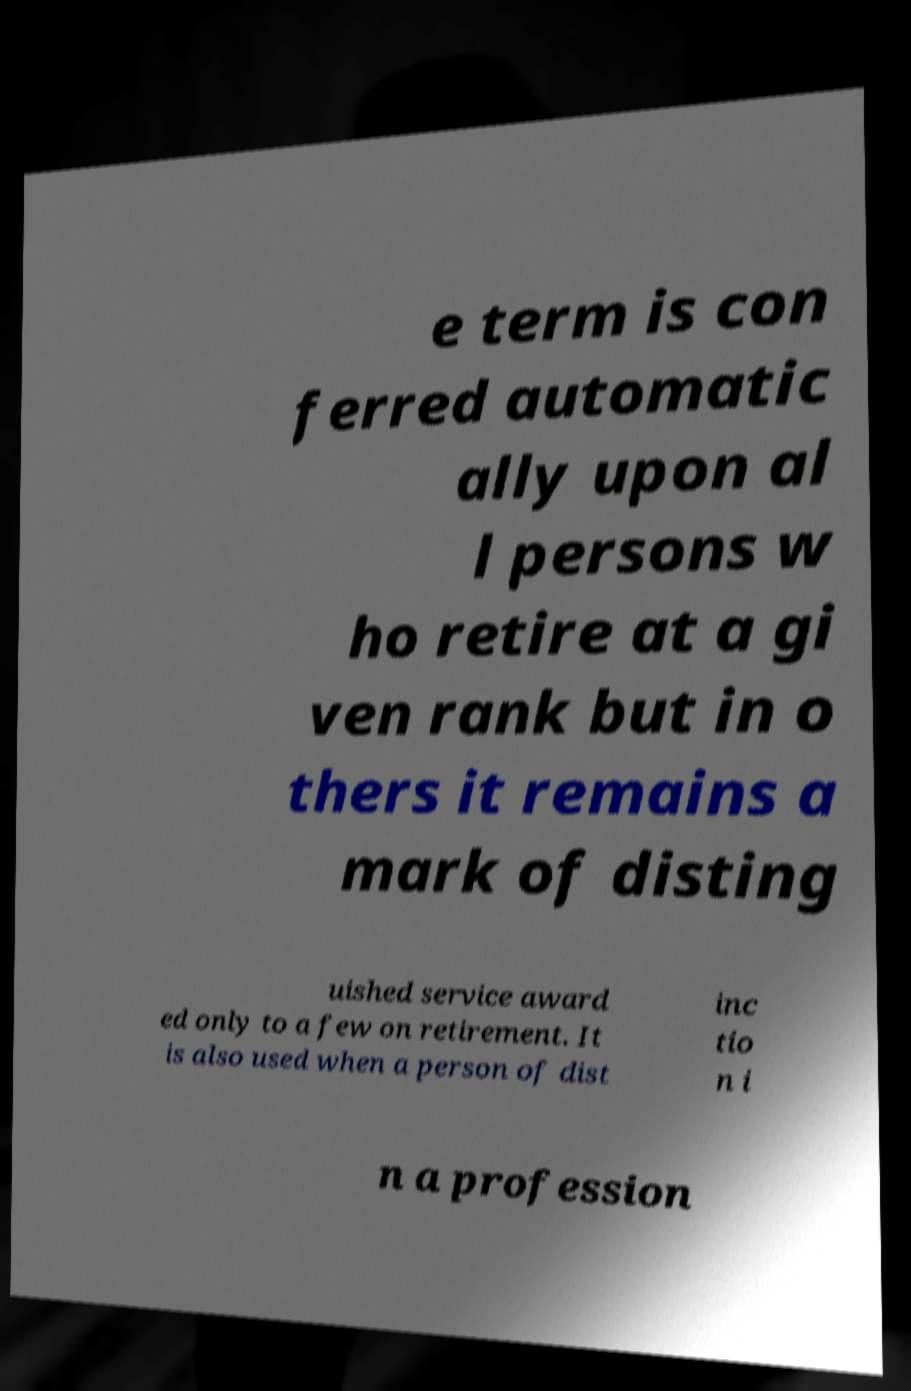I need the written content from this picture converted into text. Can you do that? e term is con ferred automatic ally upon al l persons w ho retire at a gi ven rank but in o thers it remains a mark of disting uished service award ed only to a few on retirement. It is also used when a person of dist inc tio n i n a profession 